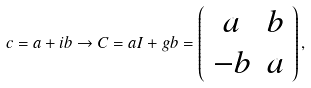<formula> <loc_0><loc_0><loc_500><loc_500>c = a + i b \rightarrow C = a I + g b = \left ( \begin{array} { c c } a & b \\ - b & a \end{array} \right ) ,</formula> 